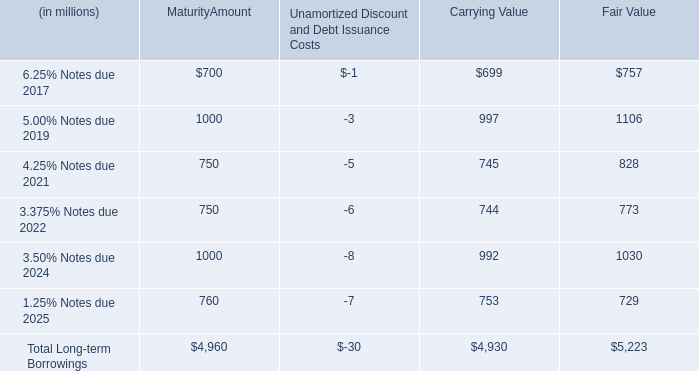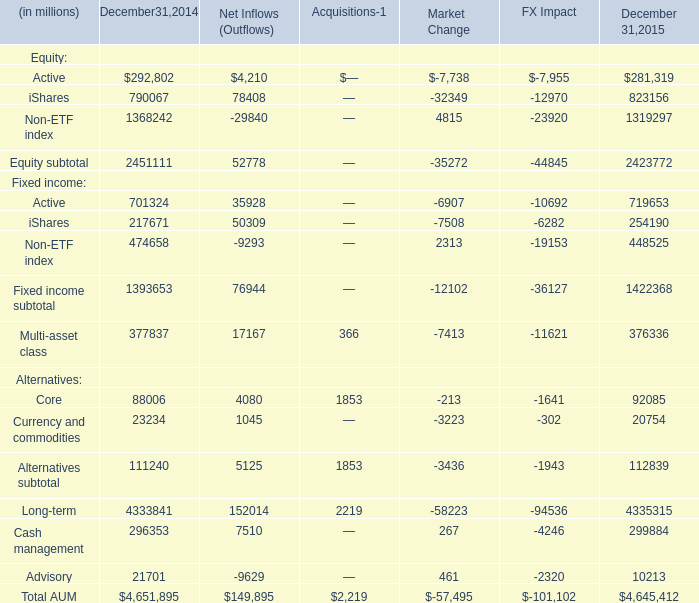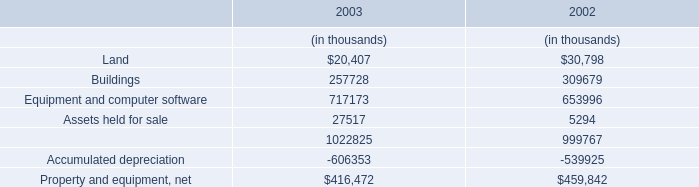What's the average of Active and iShares in 2014? (in millions) 
Computations: ((292802 + 790067) / 2)
Answer: 541434.5. 